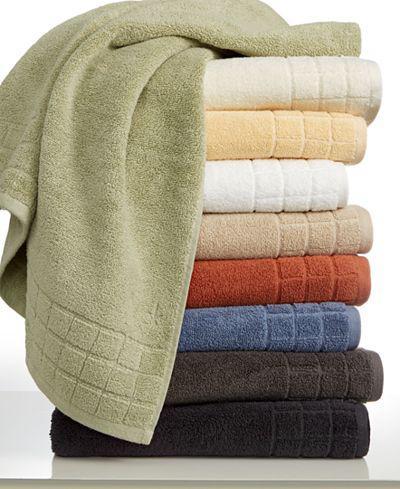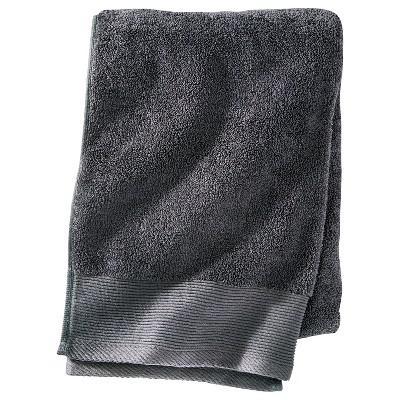The first image is the image on the left, the second image is the image on the right. Analyze the images presented: Is the assertion "Fabric color is obviously grey." valid? Answer yes or no. Yes. 